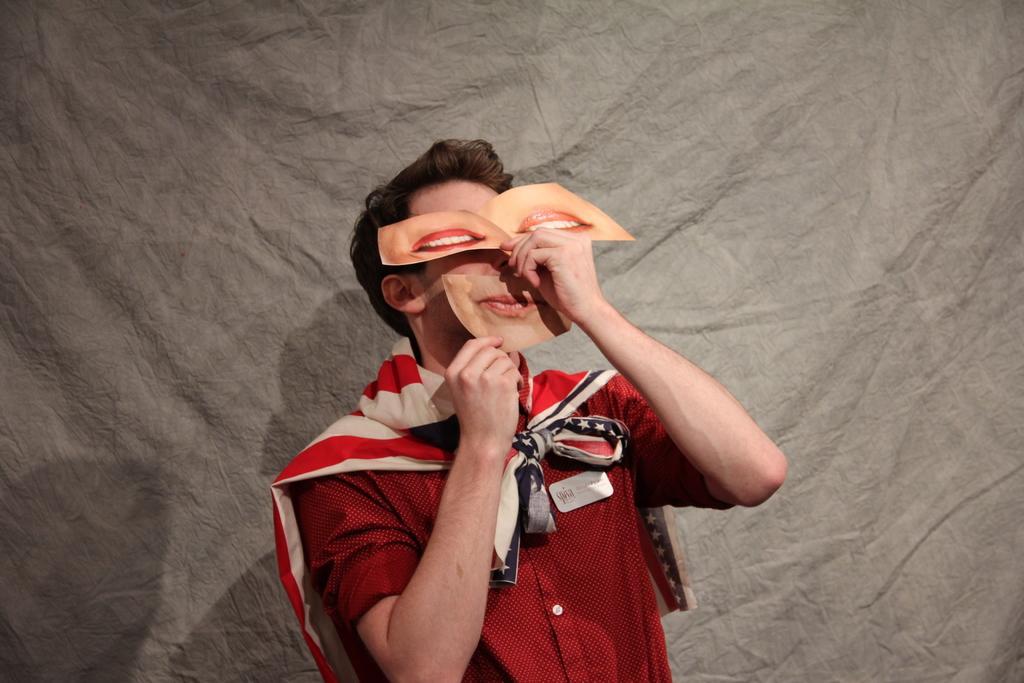How would you summarize this image in a sentence or two? In this image we can see a man is holding lips cards in his hands at his face and there is a cloth on his shoulders. In the background we can see a cloth. 